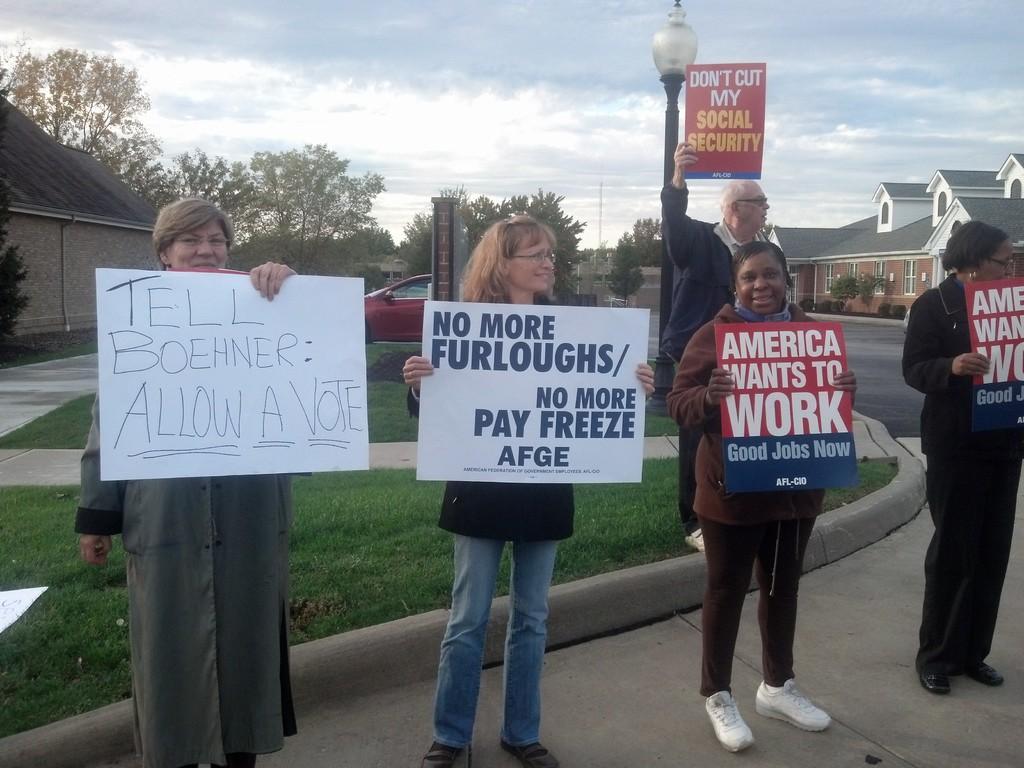Please provide a concise description of this image. In this image we can see some houses, one white board with text on the ground, one wall, one light with black pole, some objects on the ground, some poles, one red car near to the house, some people standing on the road and holding boards with text. There are some trees, bushes, plants and grass on the ground. 